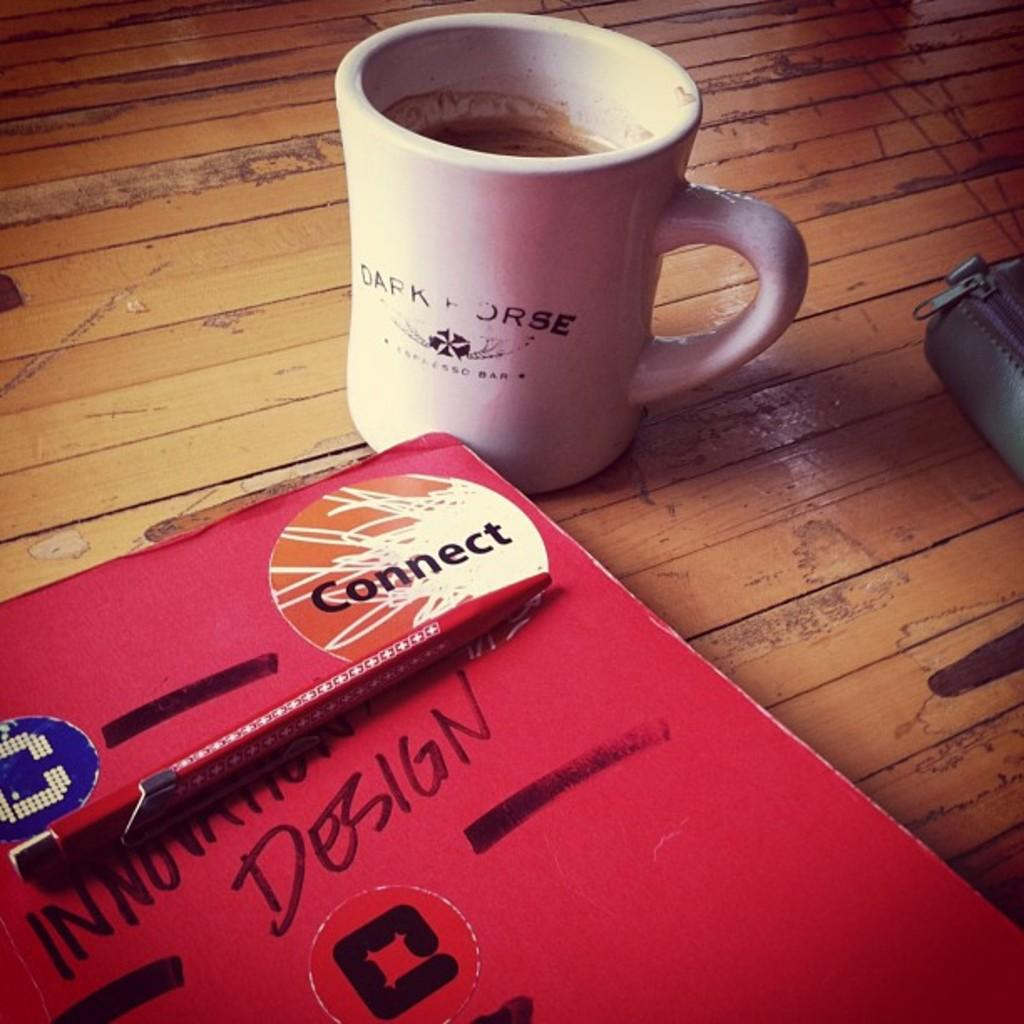<image>
Give a short and clear explanation of the subsequent image. A white coffee mug with the workds Dark Horse fading on it and a notebook with the words Innovation Design written on it 